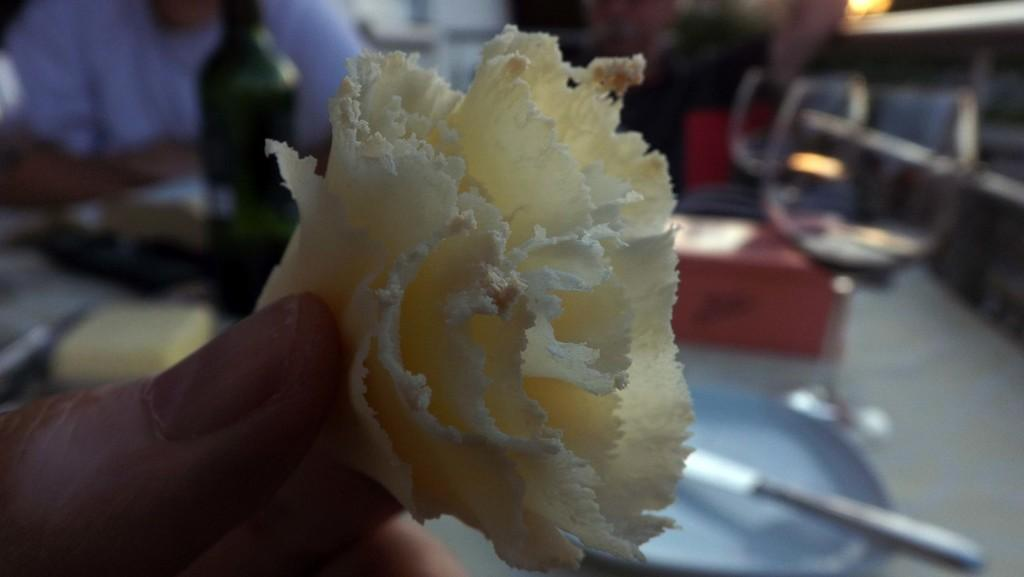What is the person holding in the image? There is a person holding a food item in the image. What can be seen in the background of the image? There is a bottle, glasses, and a plate in the background of the image. What utensil is visible on the table in the background? There is a knife on the table in the background of the image. Are there any other people visible in the image? Yes, there are other persons visible in the image. What does the bell sound like when it is rung by the servant in the image? There is no bell or servant present in the image. 